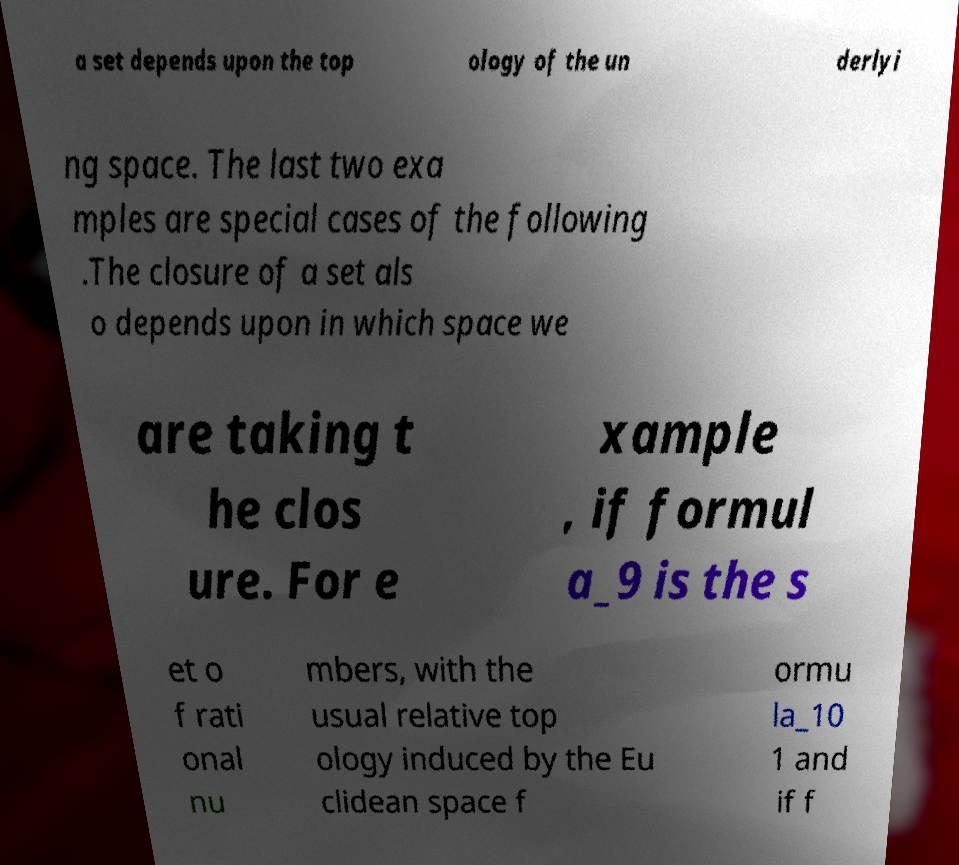What messages or text are displayed in this image? I need them in a readable, typed format. a set depends upon the top ology of the un derlyi ng space. The last two exa mples are special cases of the following .The closure of a set als o depends upon in which space we are taking t he clos ure. For e xample , if formul a_9 is the s et o f rati onal nu mbers, with the usual relative top ology induced by the Eu clidean space f ormu la_10 1 and if f 